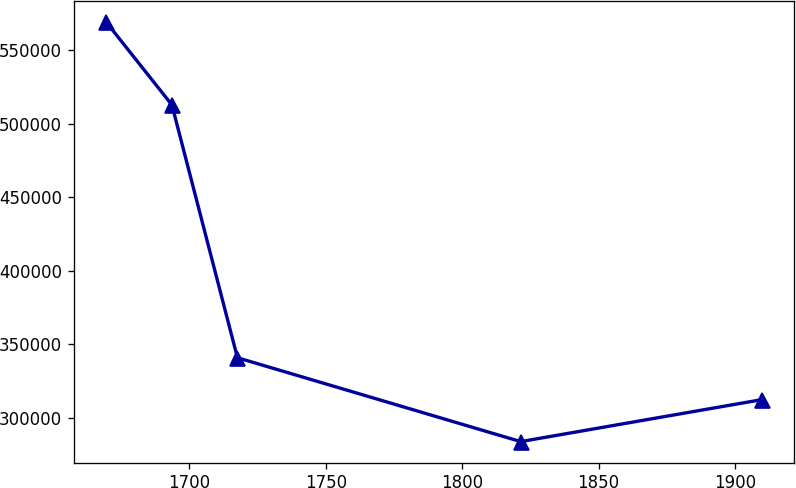Convert chart. <chart><loc_0><loc_0><loc_500><loc_500><line_chart><ecel><fcel>Unnamed: 1<nl><fcel>1669.58<fcel>569054<nl><fcel>1693.6<fcel>512865<nl><fcel>1717.62<fcel>340911<nl><fcel>1821.43<fcel>283876<nl><fcel>1909.76<fcel>312394<nl></chart> 